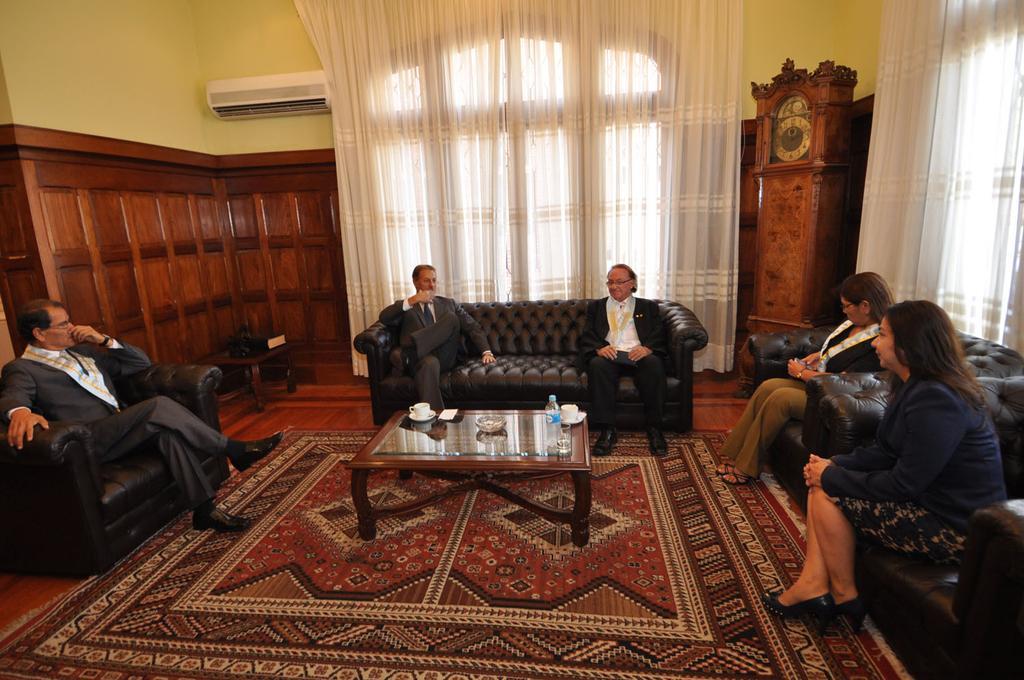How would you summarize this image in a sentence or two? In this picture we can see 5 people who are sitting on sofas. Here we can see table on which tea cups , water bottles and some bowl and water glass are present. Here there is a large mat present. In the background we can see large curtain, yellow colored walls, air conditioner, here we can see another table. It is looking like a big room. 